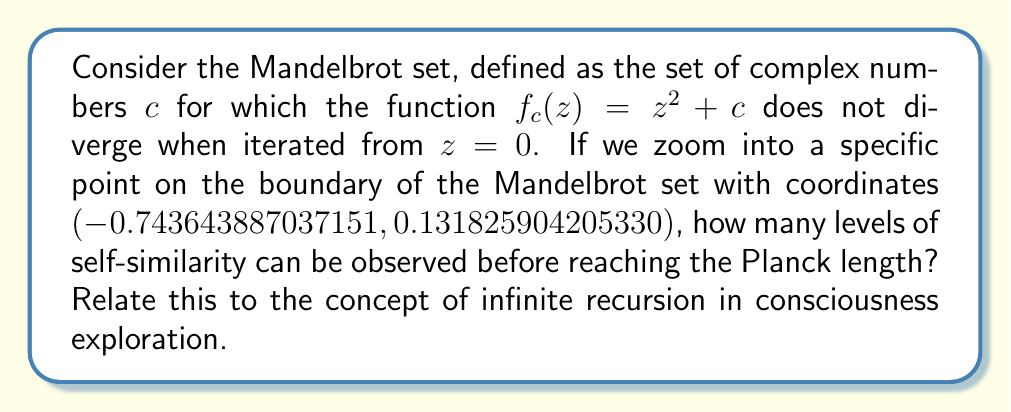Help me with this question. To approach this question, we need to consider several key points:

1. The Mandelbrot set's fractal nature:
   The Mandelbrot set exhibits self-similarity at various scales, meaning that as we zoom in, we continue to see similar patterns repeating.

2. Calculation of zoom levels:
   Let's define our starting view as 1 unit wide. Each zoom level will be a 10x magnification.
   
   Planck length ≈ $1.616 \times 10^{-35}$ meters
   
   To reach Planck length: $10^{-35} = 10^{-x}$, where x is the number of zoom levels.
   
   Solving for x: $x = 35$

3. Self-similarity in the Mandelbrot set:
   While theoretically infinite, practically, we start losing detail due to computational limitations around 10^13 magnification.

4. Relation to consciousness:
   The concept of infinite recursion in the Mandelbrot set can be seen as a metaphor for the layered nature of consciousness, where each level of awareness reveals new patterns and insights.

Calculation:
Zoom levels before computational limits: $\log_{10}(10^{13}) = 13$

Therefore, we can observe approximately 13 levels of self-similarity before reaching computational limits, which is well before reaching the Planck length at 35 levels.

This result suggests that, like consciousness exploration, our journey into the Mandelbrot set is limited not by the inherent structure itself, but by our tools of perception and analysis.
Answer: Approximately 13 levels of self-similarity can be observed before reaching computational limits, which occurs well before reaching the Planck length. This mirrors the exploration of consciousness, where our understanding is often limited by our perceptual and cognitive tools rather than the nature of consciousness itself. 